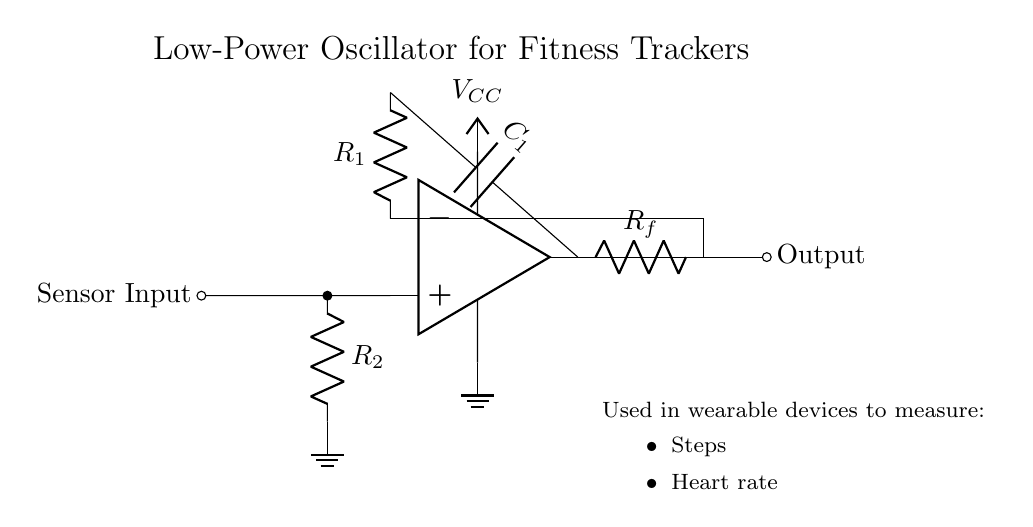What is the type of the main amplifier used in this circuit? The circuit uses an operational amplifier, which is indicated by the symbol shown.
Answer: operational amplifier What component is used for feedback in this oscillator circuit? The feedback in this circuit is provided by the resistor labeled R_f, which connects the output back to the inverting input.
Answer: R_f What is the role of capacitor C_1 in this circuit? Capacitor C_1 is used to determine the frequency of oscillation by charging and discharging, thus contributing to the timing characteristics of the oscillator.
Answer: timing What is the value of V_CC in the circuit? The circuit diagram shows a power supply labeled V_CC, which generally represents the positive voltage supply, but the exact value is not specified.
Answer: unspecified How does R_1 and R_2 affect the operational amplifier? Resistors R_1 and R_2 form a voltage divider that sets the reference voltage at the non-inverting terminal of the operational amplifier, affecting its biasing and stability.
Answer: reference voltage What is the purpose of the sensor input in this circuit? The sensor input allows the oscillator to receive inputs from sensors that monitor steps and heart rate, integrating them into its operation.
Answer: sensor monitoring What could be a potential issue if R_f is too large? If R_f is too large, it could result in instability or an improper feedback condition, causing the oscillator not to function correctly or produce a distorted output.
Answer: instability 